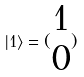<formula> <loc_0><loc_0><loc_500><loc_500>| 1 \rangle = ( \begin{matrix} 1 \\ 0 \end{matrix} )</formula> 